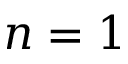Convert formula to latex. <formula><loc_0><loc_0><loc_500><loc_500>n = 1</formula> 